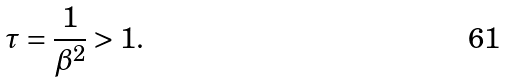Convert formula to latex. <formula><loc_0><loc_0><loc_500><loc_500>\tau = \frac { 1 } { \beta ^ { 2 } } > 1 .</formula> 